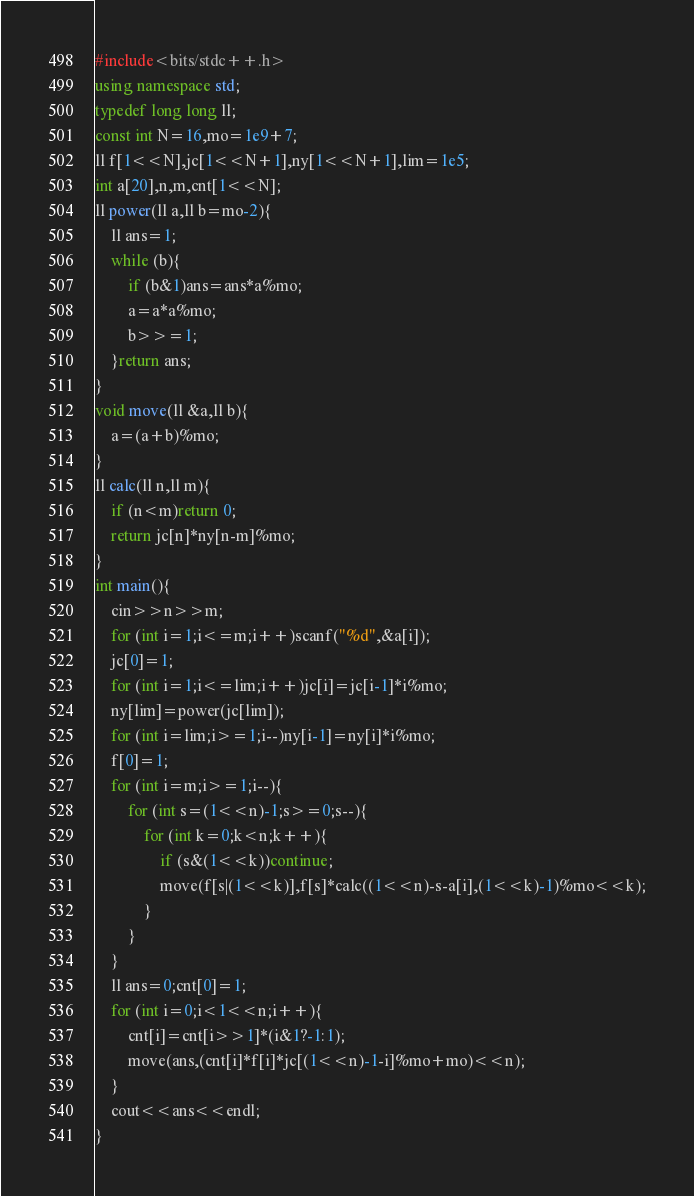<code> <loc_0><loc_0><loc_500><loc_500><_C++_>#include<bits/stdc++.h>
using namespace std;
typedef long long ll;
const int N=16,mo=1e9+7;
ll f[1<<N],jc[1<<N+1],ny[1<<N+1],lim=1e5;
int a[20],n,m,cnt[1<<N];
ll power(ll a,ll b=mo-2){
	ll ans=1;
	while (b){
		if (b&1)ans=ans*a%mo;
		a=a*a%mo;
		b>>=1;
	}return ans;
}
void move(ll &a,ll b){
	a=(a+b)%mo;
}
ll calc(ll n,ll m){
	if (n<m)return 0;
	return jc[n]*ny[n-m]%mo;
}
int main(){
	cin>>n>>m;
	for (int i=1;i<=m;i++)scanf("%d",&a[i]);
	jc[0]=1;
	for (int i=1;i<=lim;i++)jc[i]=jc[i-1]*i%mo;
	ny[lim]=power(jc[lim]);
	for (int i=lim;i>=1;i--)ny[i-1]=ny[i]*i%mo;
	f[0]=1;
	for (int i=m;i>=1;i--){
		for (int s=(1<<n)-1;s>=0;s--){
			for (int k=0;k<n;k++){
				if (s&(1<<k))continue;
				move(f[s|(1<<k)],f[s]*calc((1<<n)-s-a[i],(1<<k)-1)%mo<<k);
			}
		}
	}
	ll ans=0;cnt[0]=1;
	for (int i=0;i<1<<n;i++){
		cnt[i]=cnt[i>>1]*(i&1?-1:1);
		move(ans,(cnt[i]*f[i]*jc[(1<<n)-1-i]%mo+mo)<<n);
	}
	cout<<ans<<endl;
}</code> 